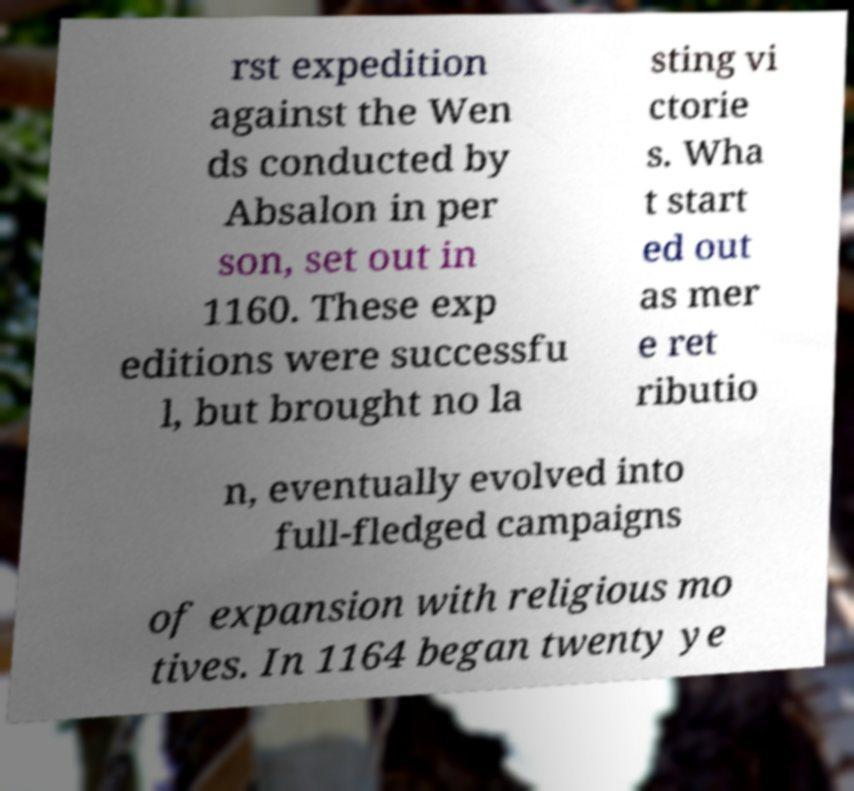Can you accurately transcribe the text from the provided image for me? rst expedition against the Wen ds conducted by Absalon in per son, set out in 1160. These exp editions were successfu l, but brought no la sting vi ctorie s. Wha t start ed out as mer e ret ributio n, eventually evolved into full-fledged campaigns of expansion with religious mo tives. In 1164 began twenty ye 